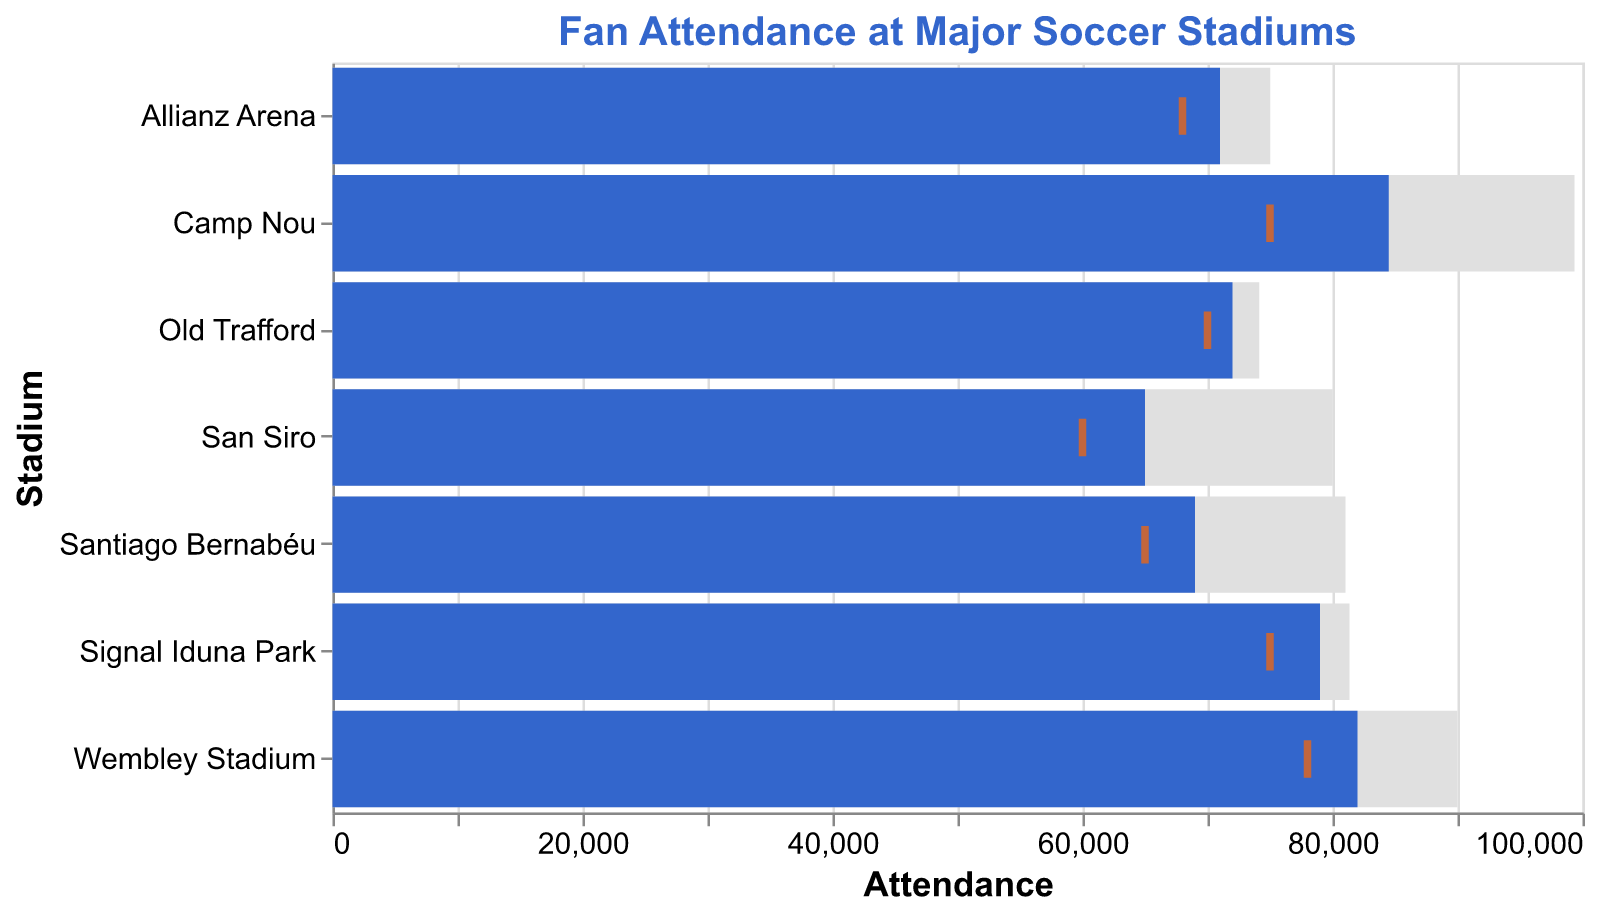How many stadiums are displayed in the figure? There are 7 data entries, each representing a different stadium.
Answer: 7 Which stadium has the highest actual attendance? The actual attendance bars show that Camp Nou has the highest actual attendance at 84,500.
Answer: Camp Nou What is the title of the figure? The title is displayed at the top of the figure. It reads "Fan Attendance at Major Soccer Stadiums".
Answer: Fan Attendance at Major Soccer Stadiums Which stadium has the closest actual attendance to its capacity? By comparing the heights of the actual attendance and stadium capacity bars, Old Trafford has the closest actual attendance to its capacity of 74,140 versus 72,000 actual attendance.
Answer: Old Trafford Which stadium has the lowest average attendance? The orange tick marks represent average attendance, showing San Siro with the lowest average attendance at 60,000.
Answer: San Siro What is the difference between the actual attendance and average attendance for Signal Iduna Park? Subtract the average attendance (75,000) from the actual attendance (79,000): 79,000 - 75,000 = 4,000.
Answer: 4,000 How does Wembley Stadium’s actual attendance compare to its capacity? The actual attendance bar for Wembley Stadium is 82,000, while the stadium capacity bar is 90,000. 82,000 is less than 90,000.
Answer: It is less Which stadiums have an actual attendance greater than 80,000? Identify the bars over 80,000: Camp Nou (84,500) and Wembley Stadium (82,000).
Answer: Camp Nou, Wembley Stadium What's the average of actual attendance across all stadiums? Summing all actual attendances: 84,500+72,000+79,000+69,000+71,000+82,000+65,000 = 522,500. Dividing by the number of stadiums (7): 522,500/7 = 74,643
Answer: 74,643 What is the median stadium capacity for the listed stadiums? Arrange capacities: 74,140, 75,024, 80,018, 81,044, 81,365, 90,000, 99,354. The median is the fourth value in an odd-numbered list, which is 81,044.
Answer: 81,044 